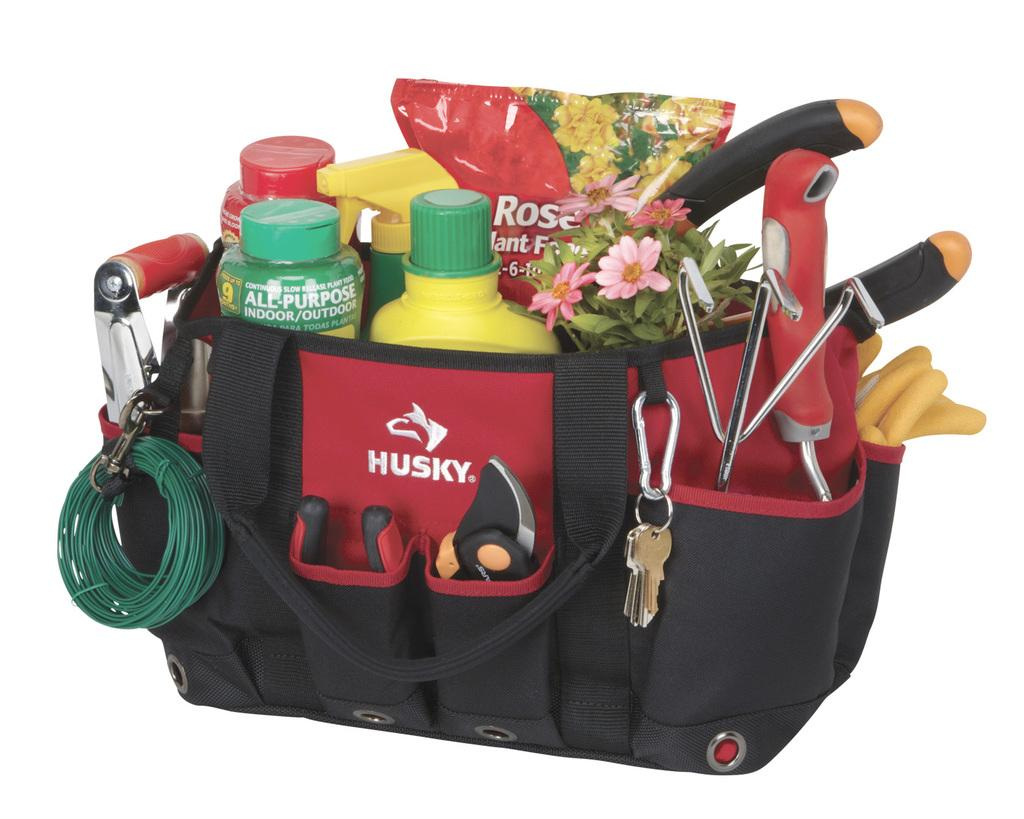What object is visible in the image that can hold items? There is a bag in the image that can hold items. What items can be seen inside the bag? There is a bottle, flowers, a wire, and keys inside the bag. Can you describe the contents of the bag in more detail? The bag contains a bottle, flowers, a wire, and keys. What time of day is it in the image, and how can you measure it? The time of day is not mentioned or visible in the image, and there is no way to measure it based on the provided facts. 